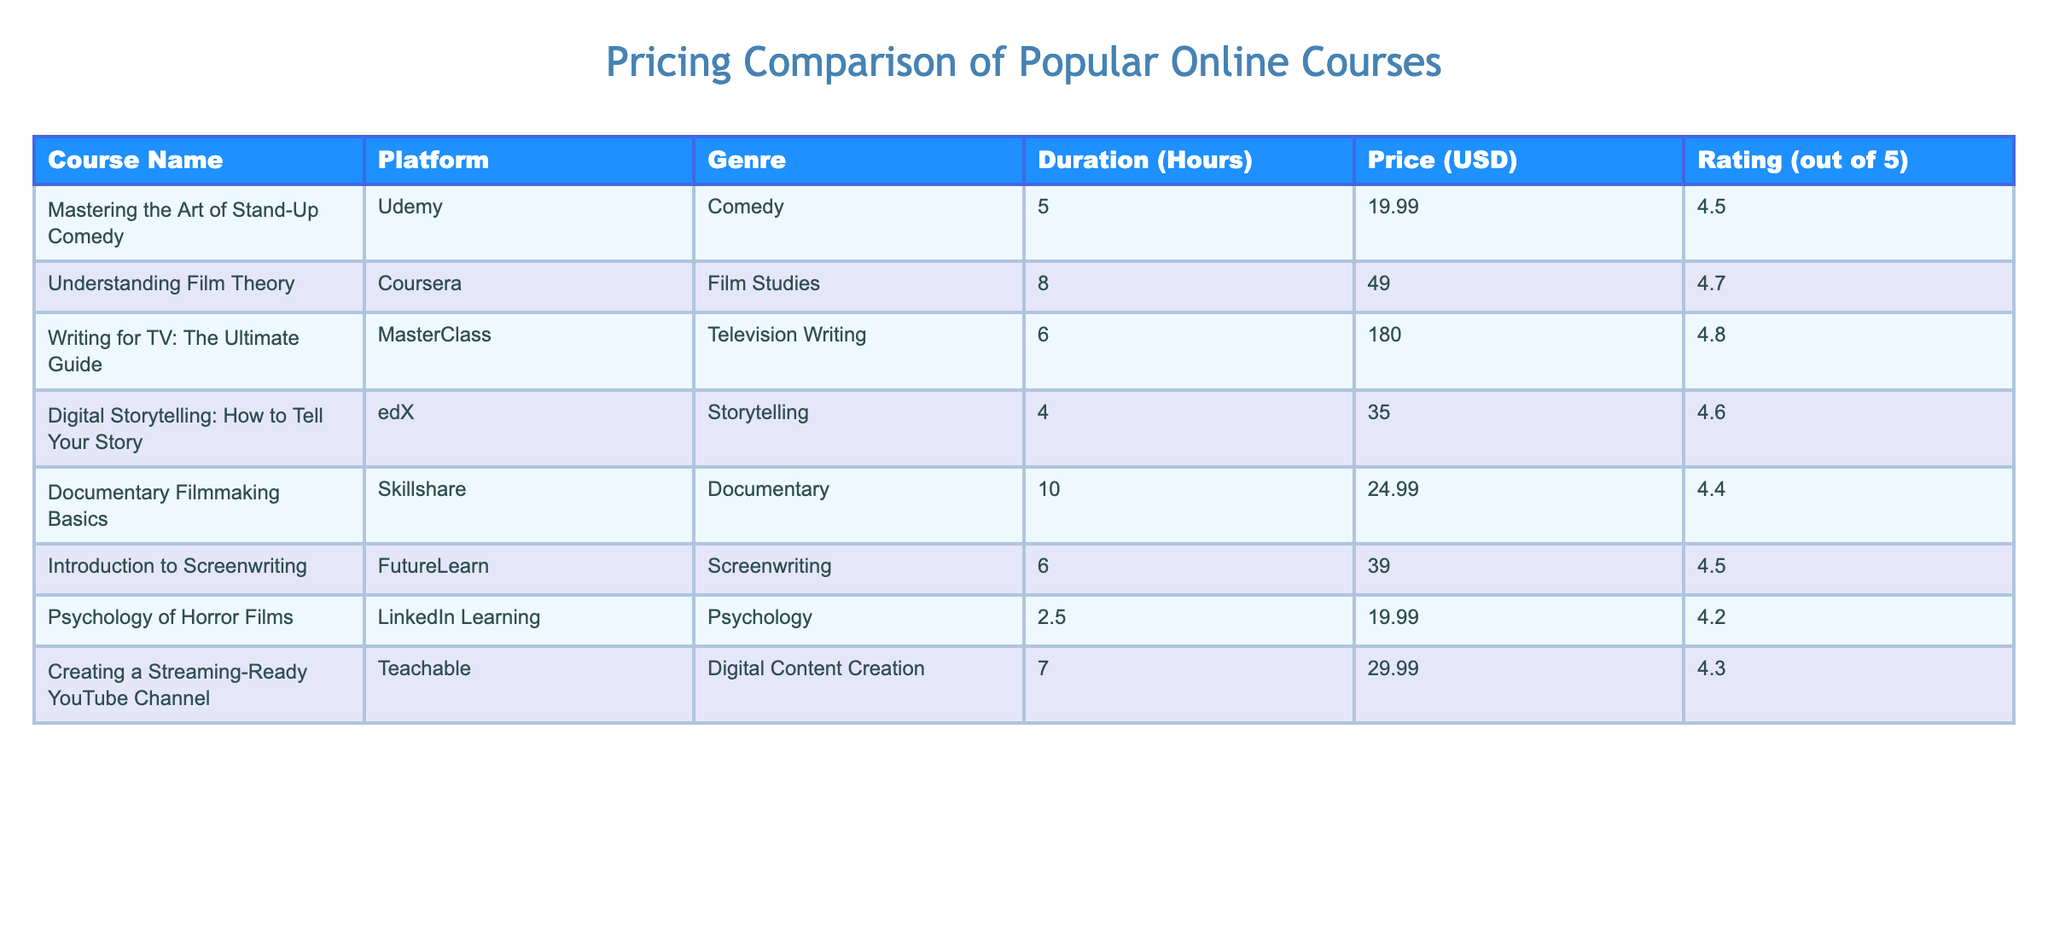What is the cheapest course available? By inspecting the table, the prices listed are 19.99, 49.00, 180.00, 35.00, 24.99, 39.00, 19.99, and 29.99. The lowest price is 19.99, which corresponds to "Mastering the Art of Stand-Up Comedy" and "Psychology of Horror Films".
Answer: 19.99 Which course has the highest rating? Reviewing the ratings in the table, the courses have ratings of 4.5, 4.7, 4.8, 4.6, 4.4, 4.5, 4.2, and 4.3. The highest rating is 4.8, which belongs to "Writing for TV: The Ultimate Guide".
Answer: 4.8 What is the total duration of all the courses combined? The durations listed are 5, 8, 6, 4, 10, 6, 2.5, and 7 hours. Adding these values together: 5 + 8 + 6 + 4 + 10 + 6 + 2.5 + 7 = 48.5 hours.
Answer: 48.5 Is the price of "Understanding Film Theory" less than 50 USD? The price for this course is 49.00 USD, which is indeed less than 50. Therefore, the statement is true.
Answer: Yes What is the average price of the courses? The prices in the table are 19.99, 49.00, 180.00, 35.00, 24.99, 39.00, 19.99, and 29.99. First, sum these up: 19.99 + 49.00 + 180.00 + 35.00 + 24.99 + 39.00 + 19.99 + 29.99 = 398.96. There are 8 courses, so the average price is 398.96 / 8 ≈ 49.87 USD.
Answer: 49.87 Which genre has the most courses listed and what are they? The genres listed are Comedy, Film Studies, Television Writing, Storytelling, Documentary, Screenwriting, Psychology, and Digital Content Creation. After counting, we see each genre has only one corresponding course, so the total for each is the same. Thus, there is no genre with more courses than others, each genre has 1 course listed.
Answer: No genre has more courses 